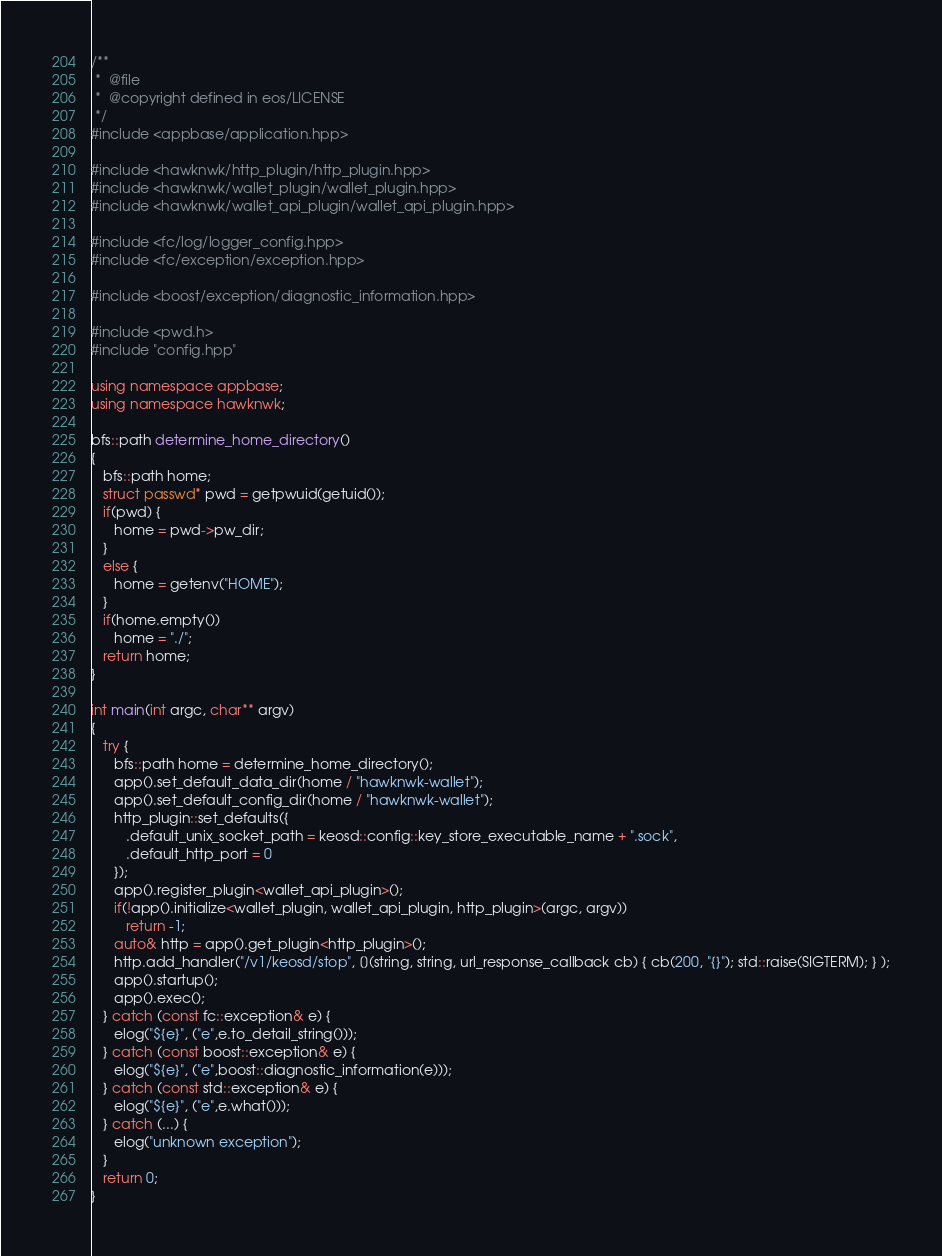<code> <loc_0><loc_0><loc_500><loc_500><_C++_>/**
 *  @file
 *  @copyright defined in eos/LICENSE
 */
#include <appbase/application.hpp>

#include <hawknwk/http_plugin/http_plugin.hpp>
#include <hawknwk/wallet_plugin/wallet_plugin.hpp>
#include <hawknwk/wallet_api_plugin/wallet_api_plugin.hpp>

#include <fc/log/logger_config.hpp>
#include <fc/exception/exception.hpp>

#include <boost/exception/diagnostic_information.hpp>

#include <pwd.h>
#include "config.hpp"

using namespace appbase;
using namespace hawknwk;

bfs::path determine_home_directory()
{
   bfs::path home;
   struct passwd* pwd = getpwuid(getuid());
   if(pwd) {
      home = pwd->pw_dir;
   }
   else {
      home = getenv("HOME");
   }
   if(home.empty())
      home = "./";
   return home;
}

int main(int argc, char** argv)
{
   try {
      bfs::path home = determine_home_directory();
      app().set_default_data_dir(home / "hawknwk-wallet");
      app().set_default_config_dir(home / "hawknwk-wallet");
      http_plugin::set_defaults({
         .default_unix_socket_path = keosd::config::key_store_executable_name + ".sock",
         .default_http_port = 0
      });
      app().register_plugin<wallet_api_plugin>();
      if(!app().initialize<wallet_plugin, wallet_api_plugin, http_plugin>(argc, argv))
         return -1;
      auto& http = app().get_plugin<http_plugin>();
      http.add_handler("/v1/keosd/stop", [](string, string, url_response_callback cb) { cb(200, "{}"); std::raise(SIGTERM); } );
      app().startup();
      app().exec();
   } catch (const fc::exception& e) {
      elog("${e}", ("e",e.to_detail_string()));
   } catch (const boost::exception& e) {
      elog("${e}", ("e",boost::diagnostic_information(e)));
   } catch (const std::exception& e) {
      elog("${e}", ("e",e.what()));
   } catch (...) {
      elog("unknown exception");
   }
   return 0;
}
</code> 